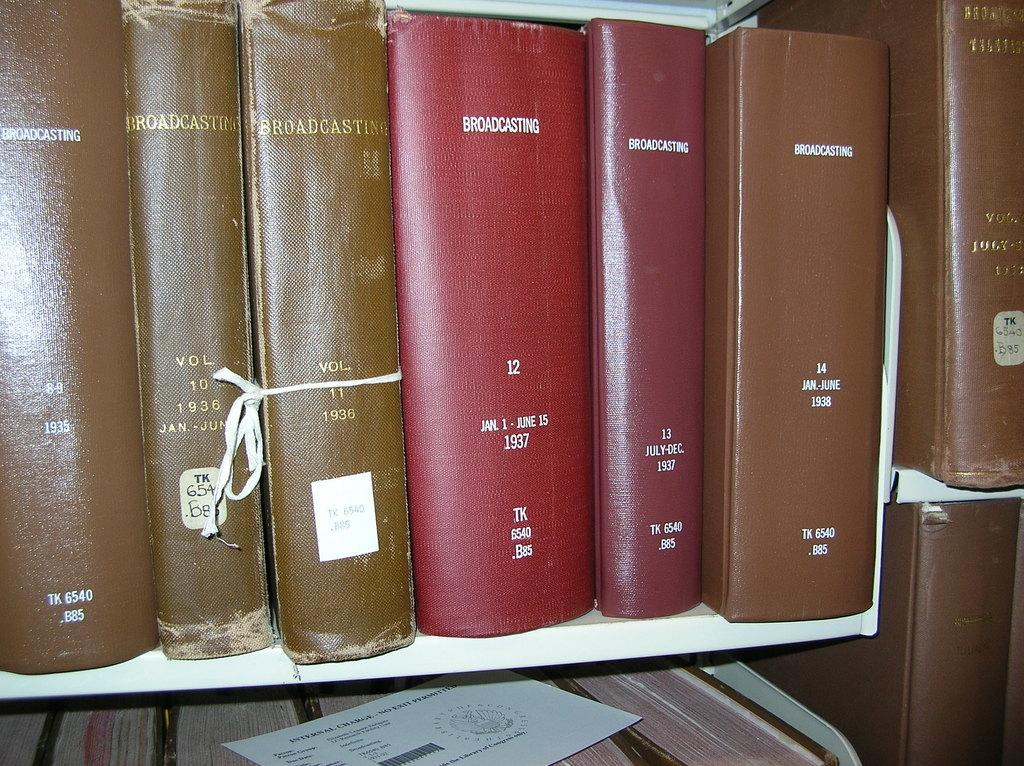<image>
Present a compact description of the photo's key features. A series of volumes titled Broadcasting with various date ranges indicated on each volume. 